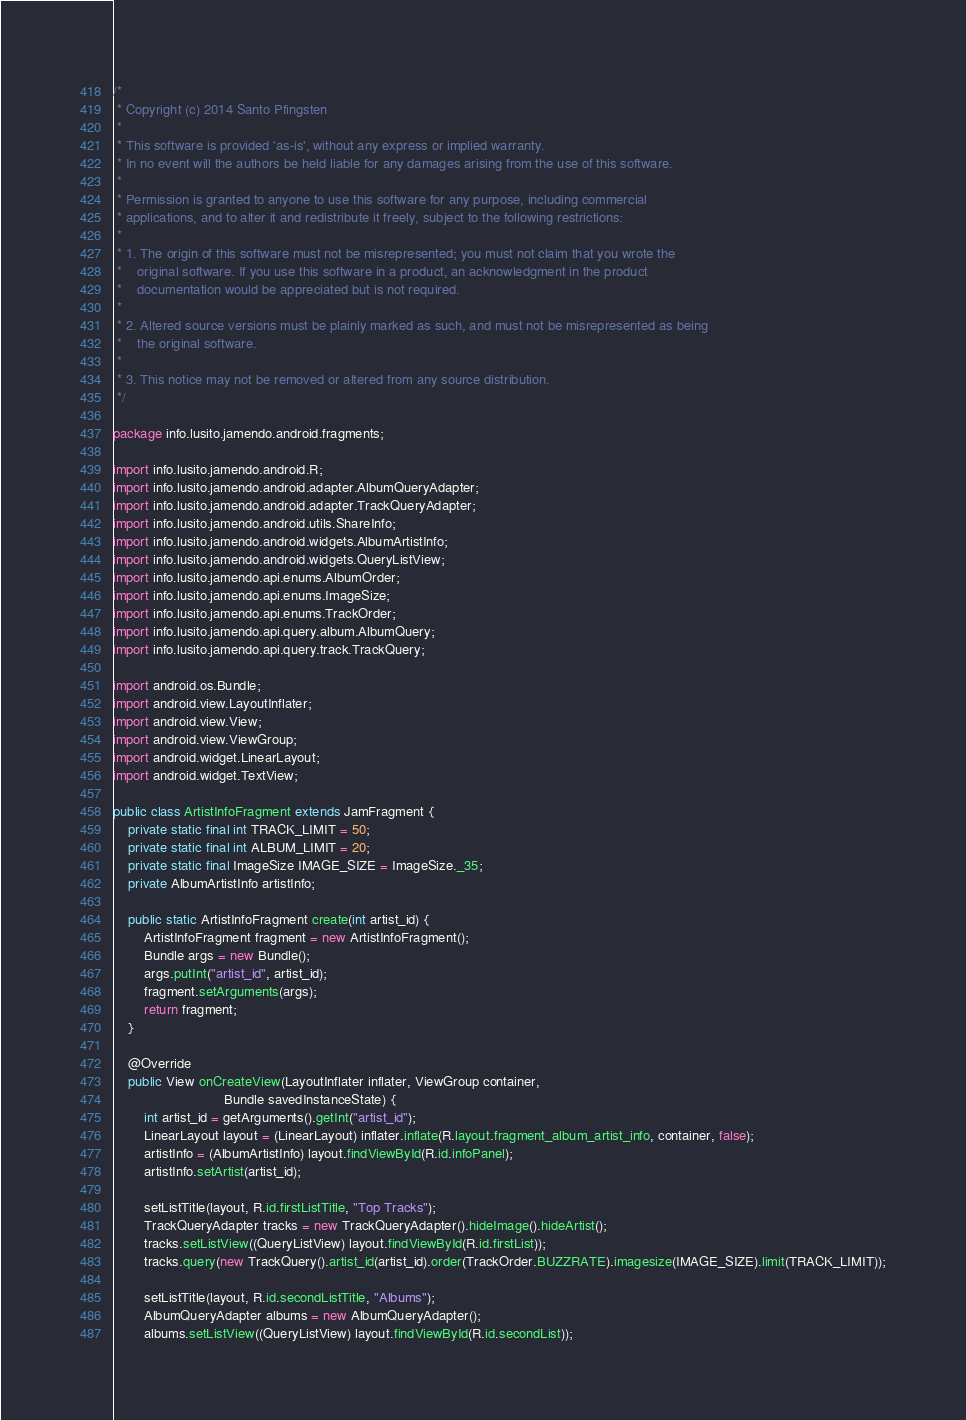<code> <loc_0><loc_0><loc_500><loc_500><_Java_>/*
 * Copyright (c) 2014 Santo Pfingsten
 *
 * This software is provided 'as-is', without any express or implied warranty.
 * In no event will the authors be held liable for any damages arising from the use of this software.
 *
 * Permission is granted to anyone to use this software for any purpose, including commercial
 * applications, and to alter it and redistribute it freely, subject to the following restrictions:
 *
 * 1. The origin of this software must not be misrepresented; you must not claim that you wrote the
 *    original software. If you use this software in a product, an acknowledgment in the product
 *    documentation would be appreciated but is not required.
 *
 * 2. Altered source versions must be plainly marked as such, and must not be misrepresented as being
 *    the original software.
 *
 * 3. This notice may not be removed or altered from any source distribution.
 */

package info.lusito.jamendo.android.fragments;

import info.lusito.jamendo.android.R;
import info.lusito.jamendo.android.adapter.AlbumQueryAdapter;
import info.lusito.jamendo.android.adapter.TrackQueryAdapter;
import info.lusito.jamendo.android.utils.ShareInfo;
import info.lusito.jamendo.android.widgets.AlbumArtistInfo;
import info.lusito.jamendo.android.widgets.QueryListView;
import info.lusito.jamendo.api.enums.AlbumOrder;
import info.lusito.jamendo.api.enums.ImageSize;
import info.lusito.jamendo.api.enums.TrackOrder;
import info.lusito.jamendo.api.query.album.AlbumQuery;
import info.lusito.jamendo.api.query.track.TrackQuery;

import android.os.Bundle;
import android.view.LayoutInflater;
import android.view.View;
import android.view.ViewGroup;
import android.widget.LinearLayout;
import android.widget.TextView;

public class ArtistInfoFragment extends JamFragment {
    private static final int TRACK_LIMIT = 50;
    private static final int ALBUM_LIMIT = 20;
    private static final ImageSize IMAGE_SIZE = ImageSize._35;
    private AlbumArtistInfo artistInfo;

    public static ArtistInfoFragment create(int artist_id) {
        ArtistInfoFragment fragment = new ArtistInfoFragment();
        Bundle args = new Bundle();
        args.putInt("artist_id", artist_id);
        fragment.setArguments(args);
        return fragment;
    }

    @Override
    public View onCreateView(LayoutInflater inflater, ViewGroup container,
                             Bundle savedInstanceState) {
        int artist_id = getArguments().getInt("artist_id");
        LinearLayout layout = (LinearLayout) inflater.inflate(R.layout.fragment_album_artist_info, container, false);
        artistInfo = (AlbumArtistInfo) layout.findViewById(R.id.infoPanel);
        artistInfo.setArtist(artist_id);

        setListTitle(layout, R.id.firstListTitle, "Top Tracks");
        TrackQueryAdapter tracks = new TrackQueryAdapter().hideImage().hideArtist();
        tracks.setListView((QueryListView) layout.findViewById(R.id.firstList));
        tracks.query(new TrackQuery().artist_id(artist_id).order(TrackOrder.BUZZRATE).imagesize(IMAGE_SIZE).limit(TRACK_LIMIT));

        setListTitle(layout, R.id.secondListTitle, "Albums");
        AlbumQueryAdapter albums = new AlbumQueryAdapter();
        albums.setListView((QueryListView) layout.findViewById(R.id.secondList));</code> 